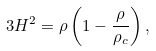<formula> <loc_0><loc_0><loc_500><loc_500>3 H ^ { 2 } = \rho \left ( 1 - \frac { \rho } { \rho _ { c } } \right ) ,</formula> 